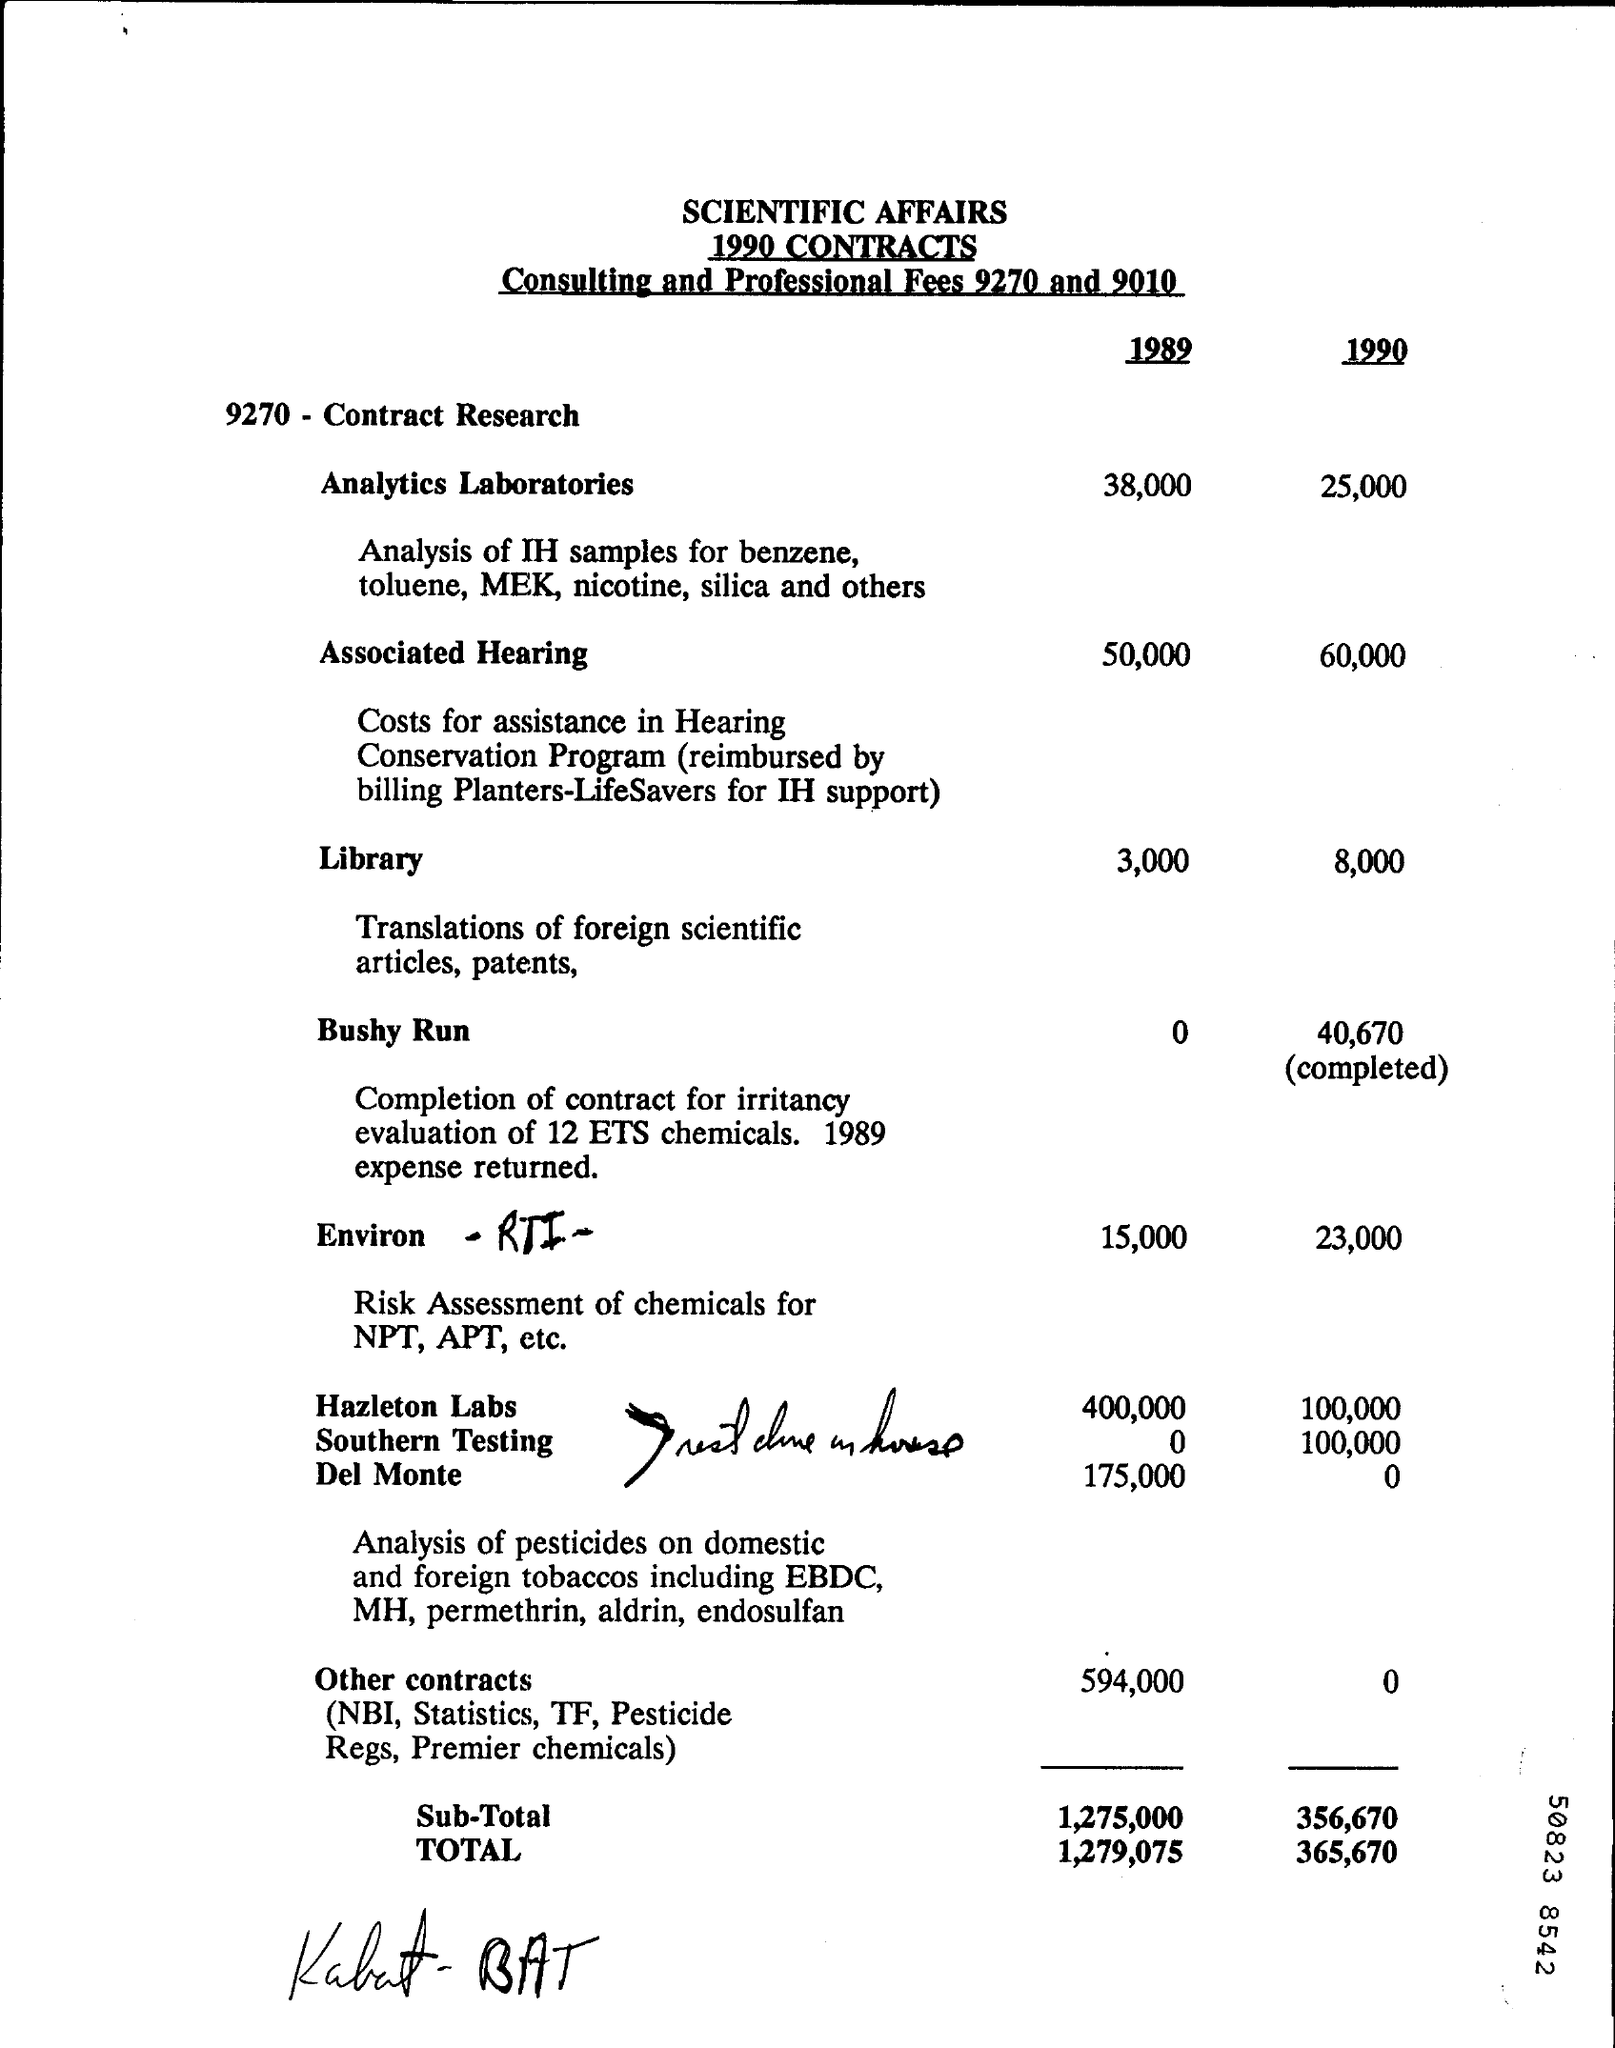Mention a couple of crucial points in this snapshot. In 1990, the fee for the library was 8,000. The total cost in 1990 was 365,670. In 1990, the Associated Hearing fee was $60,000. In 1989, the fee for the library was 3,000. In 1990, the fee for Analytics Laboratories was 25,000. 